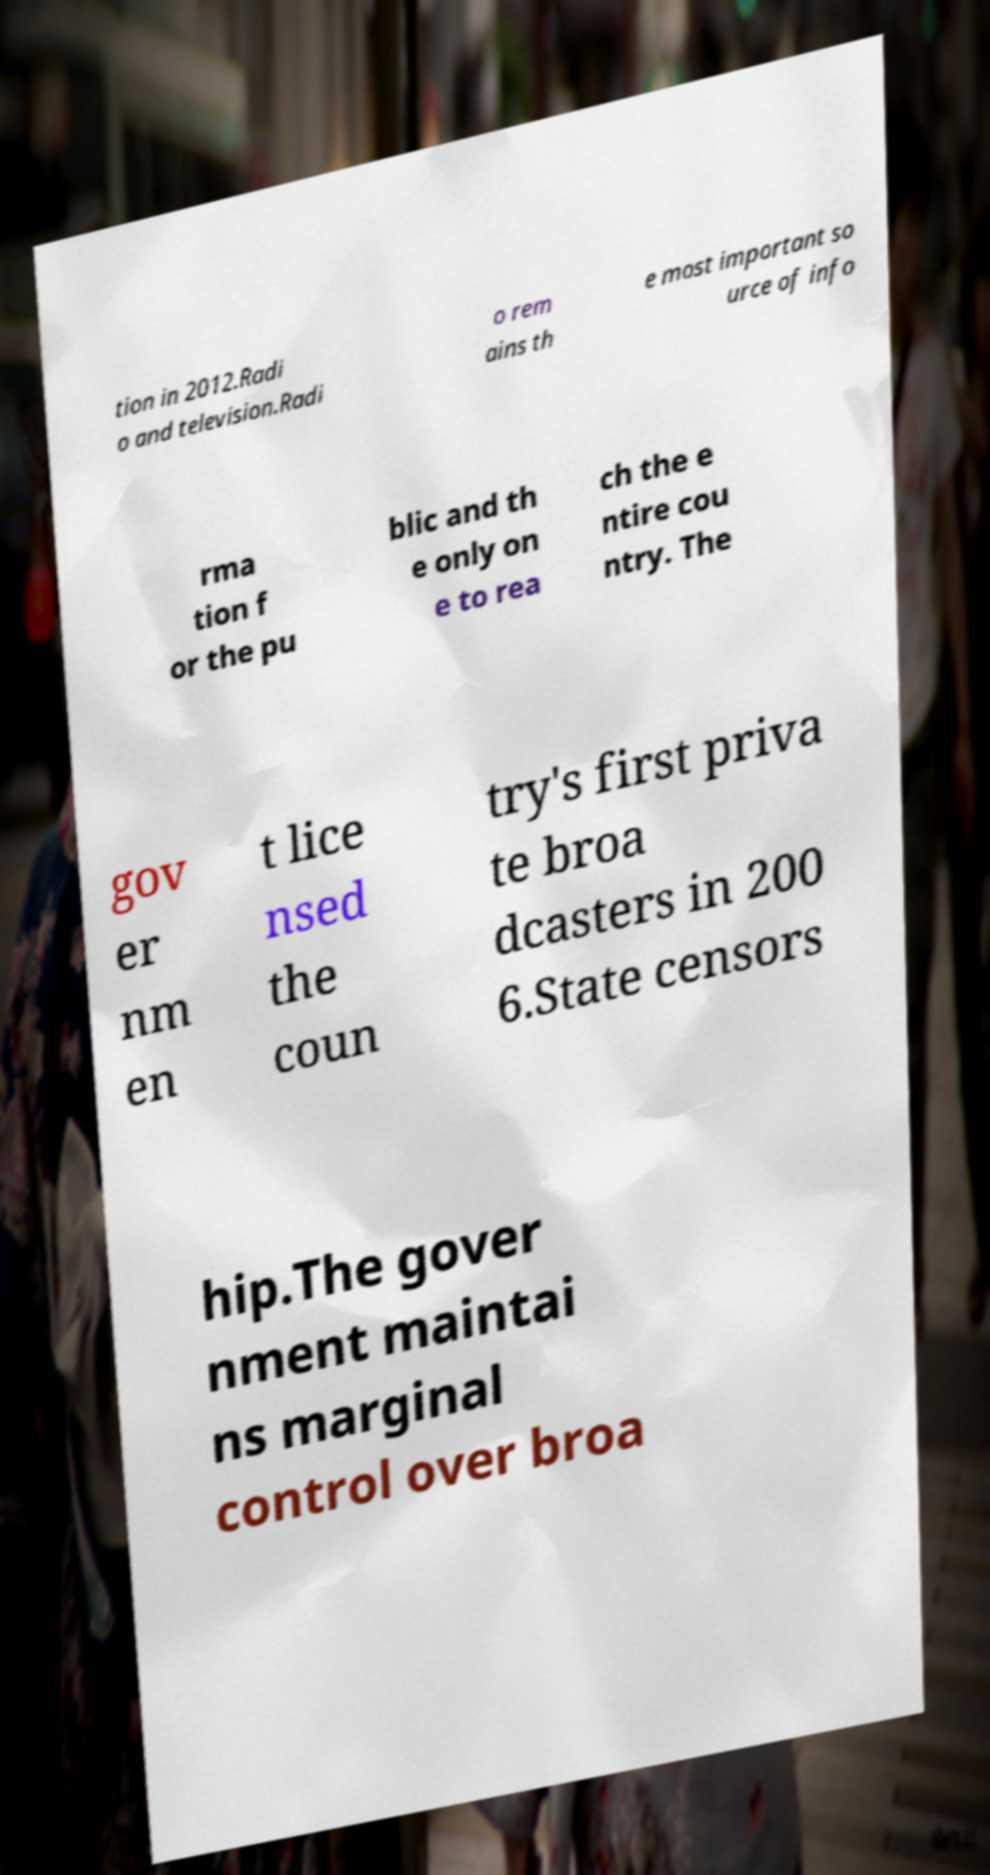Please identify and transcribe the text found in this image. tion in 2012.Radi o and television.Radi o rem ains th e most important so urce of info rma tion f or the pu blic and th e only on e to rea ch the e ntire cou ntry. The gov er nm en t lice nsed the coun try's first priva te broa dcasters in 200 6.State censors hip.The gover nment maintai ns marginal control over broa 